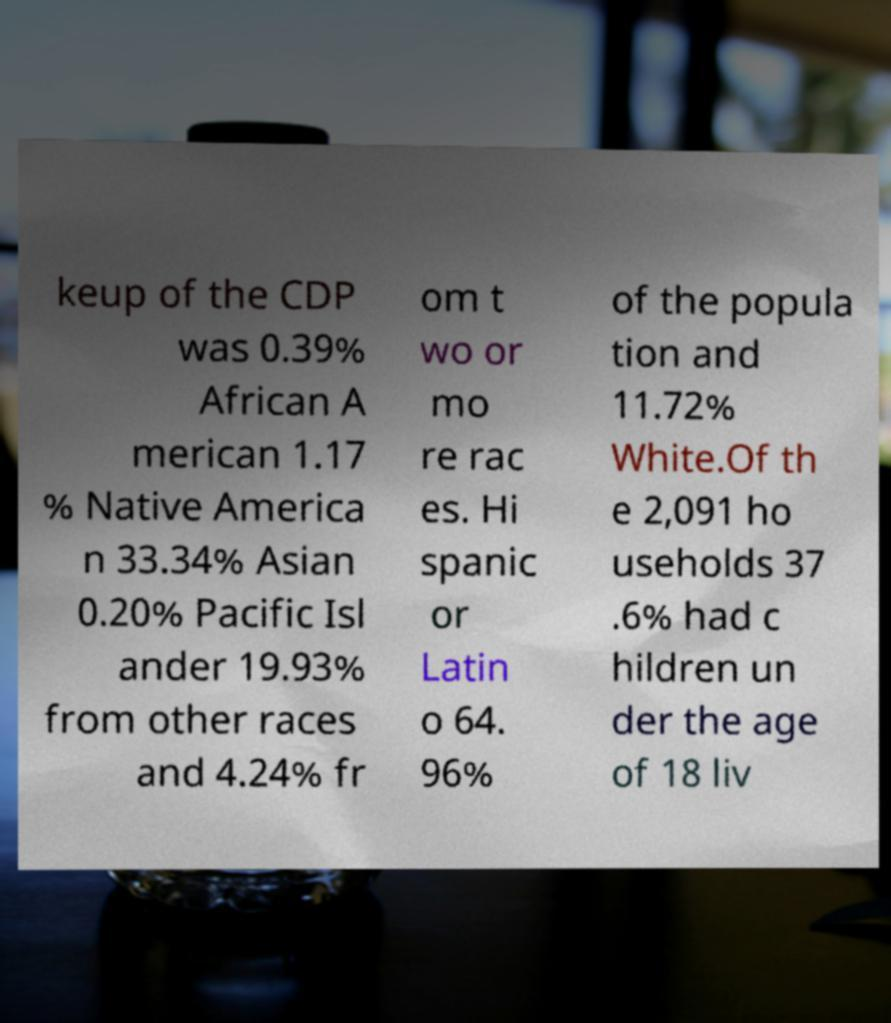Can you read and provide the text displayed in the image?This photo seems to have some interesting text. Can you extract and type it out for me? keup of the CDP was 0.39% African A merican 1.17 % Native America n 33.34% Asian 0.20% Pacific Isl ander 19.93% from other races and 4.24% fr om t wo or mo re rac es. Hi spanic or Latin o 64. 96% of the popula tion and 11.72% White.Of th e 2,091 ho useholds 37 .6% had c hildren un der the age of 18 liv 